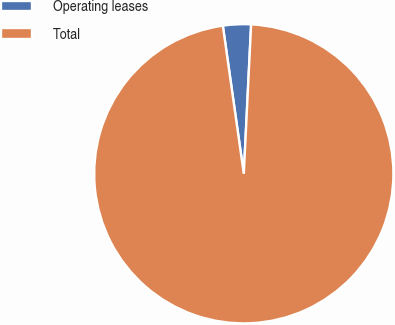<chart> <loc_0><loc_0><loc_500><loc_500><pie_chart><fcel>Operating leases<fcel>Total<nl><fcel>3.02%<fcel>96.98%<nl></chart> 